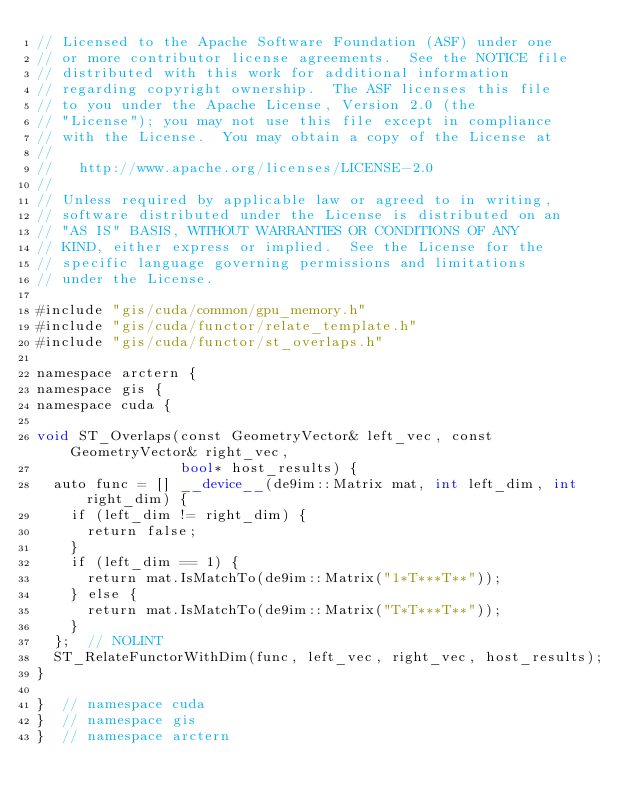<code> <loc_0><loc_0><loc_500><loc_500><_Cuda_>// Licensed to the Apache Software Foundation (ASF) under one
// or more contributor license agreements.  See the NOTICE file
// distributed with this work for additional information
// regarding copyright ownership.  The ASF licenses this file
// to you under the Apache License, Version 2.0 (the
// "License"); you may not use this file except in compliance
// with the License.  You may obtain a copy of the License at
//
//   http://www.apache.org/licenses/LICENSE-2.0
//
// Unless required by applicable law or agreed to in writing,
// software distributed under the License is distributed on an
// "AS IS" BASIS, WITHOUT WARRANTIES OR CONDITIONS OF ANY
// KIND, either express or implied.  See the License for the
// specific language governing permissions and limitations
// under the License.

#include "gis/cuda/common/gpu_memory.h"
#include "gis/cuda/functor/relate_template.h"
#include "gis/cuda/functor/st_overlaps.h"

namespace arctern {
namespace gis {
namespace cuda {

void ST_Overlaps(const GeometryVector& left_vec, const GeometryVector& right_vec,
                 bool* host_results) {
  auto func = [] __device__(de9im::Matrix mat, int left_dim, int right_dim) {
    if (left_dim != right_dim) {
      return false;
    }
    if (left_dim == 1) {
      return mat.IsMatchTo(de9im::Matrix("1*T***T**"));
    } else {
      return mat.IsMatchTo(de9im::Matrix("T*T***T**"));
    }
  };  // NOLINT
  ST_RelateFunctorWithDim(func, left_vec, right_vec, host_results);
}

}  // namespace cuda
}  // namespace gis
}  // namespace arctern
</code> 